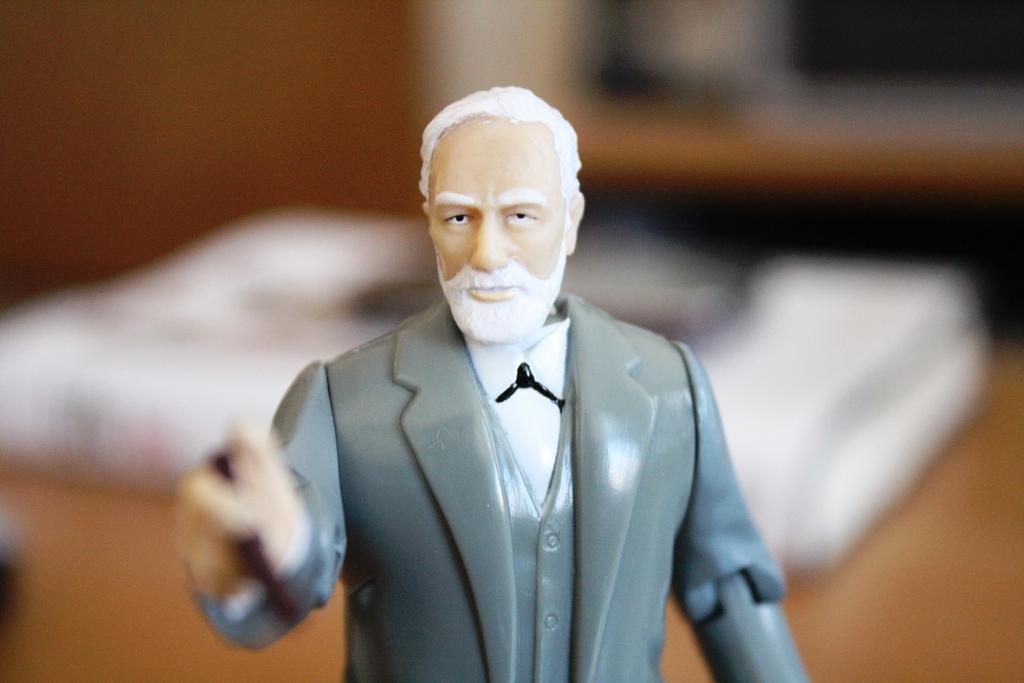What is the main subject in the middle of the image? There is a toy in the middle of the image. Can you describe the background of the image? The background of the image is blurry. What type of pest can be seen crawling on the toy in the image? There is no pest visible on the toy in the image. How many people are in the crowd surrounding the toy in the image? There is no crowd present in the image; it only features the toy and a blurry background. 